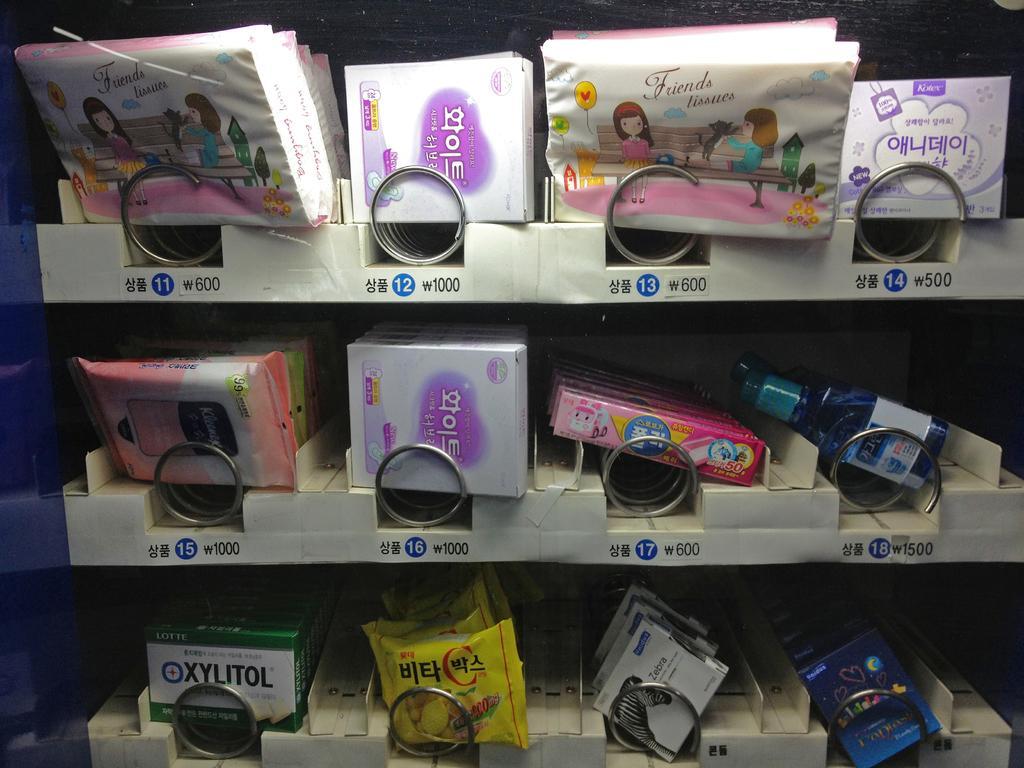Please provide a concise description of this image. In this picture we can see shelves and in the shelves there are boxes, bottles and different items. 